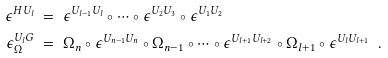<formula> <loc_0><loc_0><loc_500><loc_500>\epsilon ^ { H U _ { l } } & \ = \ \epsilon ^ { U _ { l - 1 } U _ { l } } \circ \cdots \circ \epsilon ^ { U _ { 2 } U _ { 3 } } \circ \epsilon ^ { U _ { 1 } U _ { 2 } } \\ \epsilon _ { \Omega } ^ { U _ { l } G } & \ = \ \Omega _ { n } \circ \epsilon ^ { U _ { n - 1 } U _ { n } } \circ \Omega _ { n - 1 } \circ \cdots \circ \epsilon ^ { U _ { l + 1 } U _ { l + 2 } } \circ \Omega _ { l + 1 } \circ \epsilon ^ { U _ { l } U _ { l + 1 } } \ \ .</formula> 